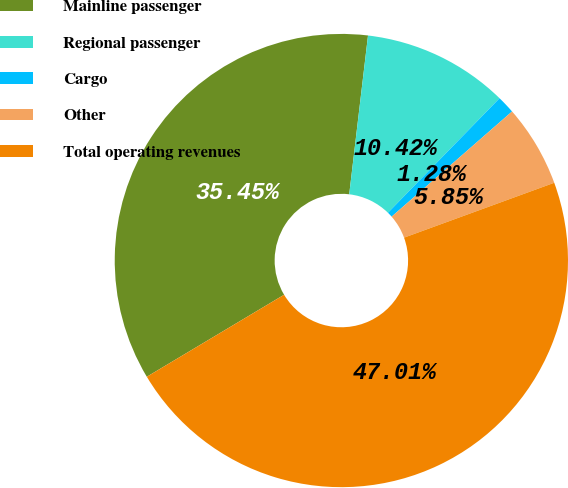Convert chart. <chart><loc_0><loc_0><loc_500><loc_500><pie_chart><fcel>Mainline passenger<fcel>Regional passenger<fcel>Cargo<fcel>Other<fcel>Total operating revenues<nl><fcel>35.45%<fcel>10.42%<fcel>1.28%<fcel>5.85%<fcel>47.01%<nl></chart> 